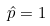<formula> <loc_0><loc_0><loc_500><loc_500>\hat { p } = 1</formula> 